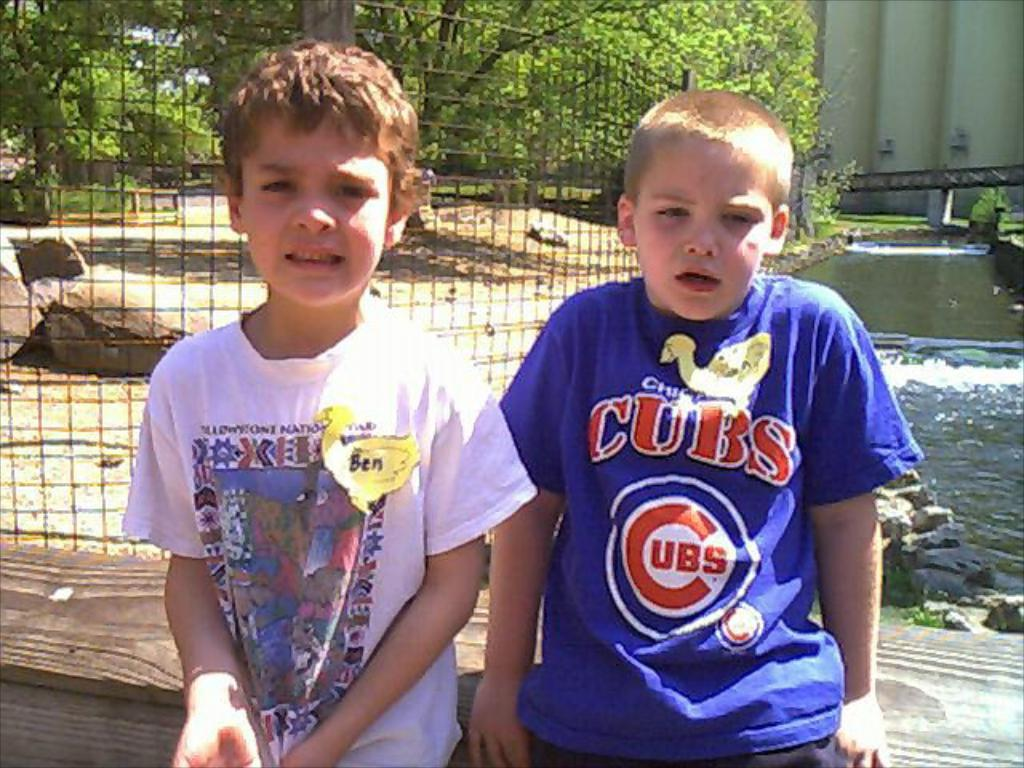<image>
Provide a brief description of the given image. A boy wearing a blue Cubs t-shirt sits next to another little boy. 